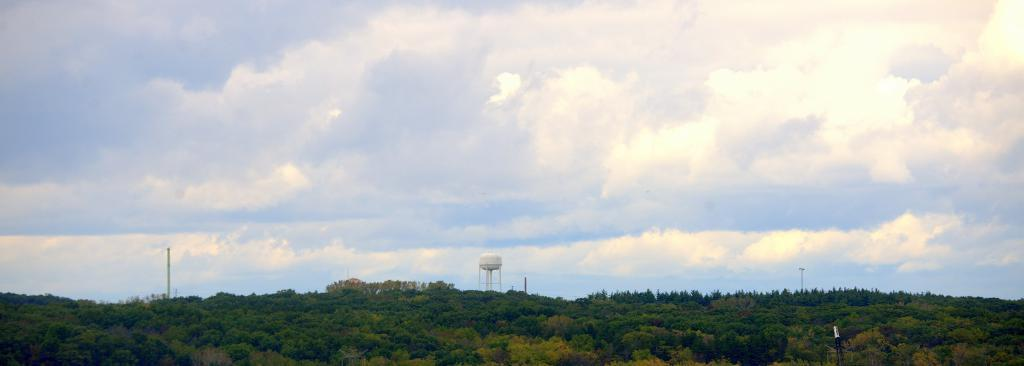What is located in the center of the image? There are trees in the center of the image. What structure can be seen in the image? There is a tower in the image. What objects are present in the image besides the trees and tower? There are poles in the image. How would you describe the sky in the image? The sky is cloudy in the image. What type of impulse can be seen affecting the trees in the image? There is no impulse affecting the trees in the image; they are stationary. Is the image taken during winter, given the presence of trees and a cloudy sky? The provided facts do not indicate the season, so we cannot determine if the image is taken during winter. 